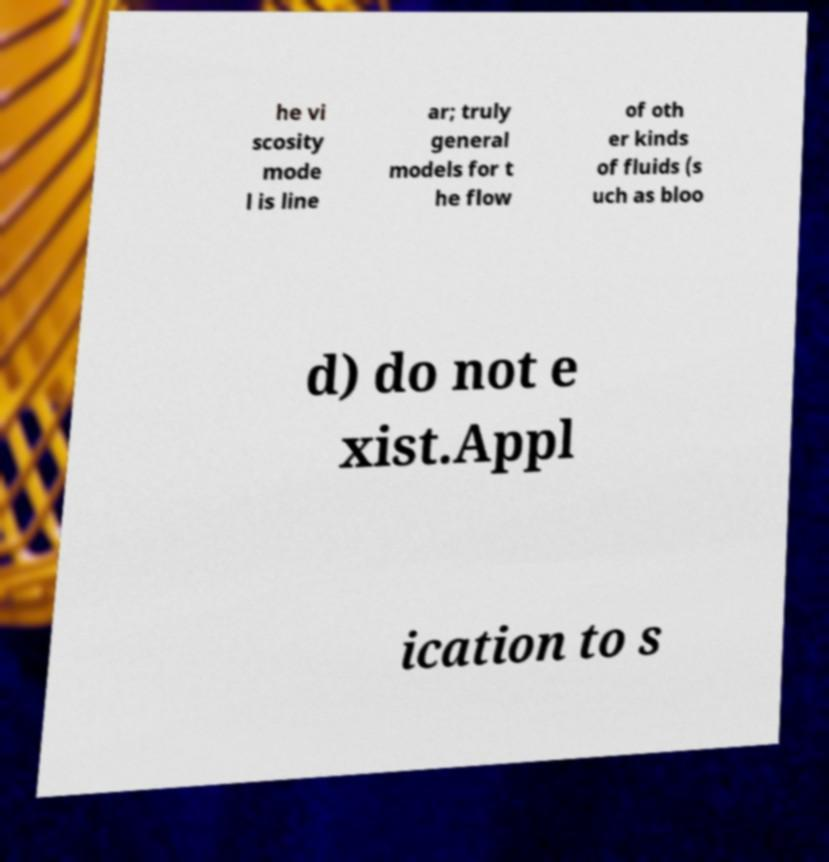For documentation purposes, I need the text within this image transcribed. Could you provide that? he vi scosity mode l is line ar; truly general models for t he flow of oth er kinds of fluids (s uch as bloo d) do not e xist.Appl ication to s 